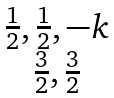Convert formula to latex. <formula><loc_0><loc_0><loc_500><loc_500>\begin{matrix} { \frac { 1 } { 2 } , \frac { 1 } { 2 } , - k } \\ { \frac { 3 } { 2 } , \frac { 3 } { 2 } } \end{matrix}</formula> 